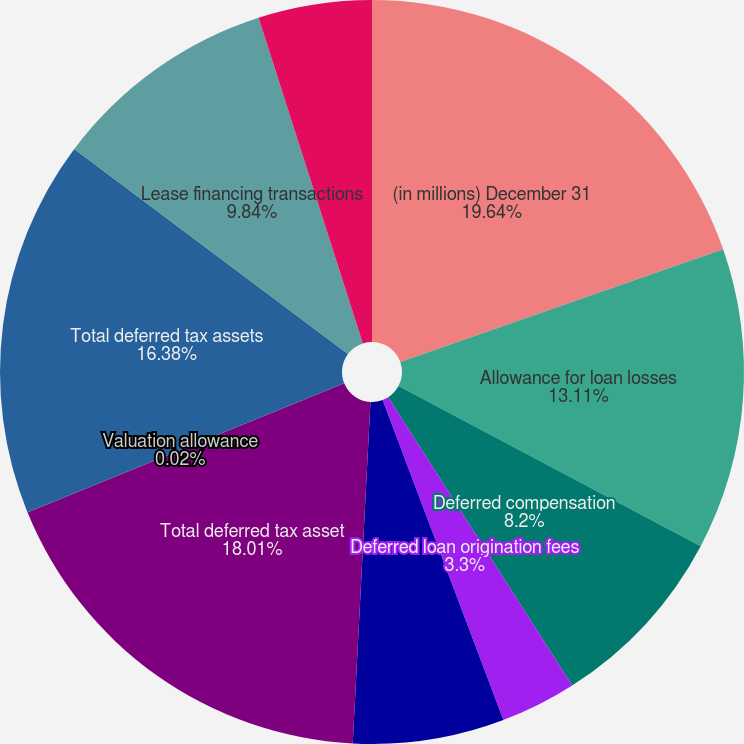Convert chart. <chart><loc_0><loc_0><loc_500><loc_500><pie_chart><fcel>(in millions) December 31<fcel>Allowance for loan losses<fcel>Deferred compensation<fcel>Deferred loan origination fees<fcel>Other temporary differences<fcel>Total deferred tax asset<fcel>Valuation allowance<fcel>Total deferred tax assets<fcel>Lease financing transactions<fcel>Defined benefit plans<nl><fcel>19.65%<fcel>13.11%<fcel>8.2%<fcel>3.3%<fcel>6.57%<fcel>18.01%<fcel>0.02%<fcel>16.38%<fcel>9.84%<fcel>4.93%<nl></chart> 